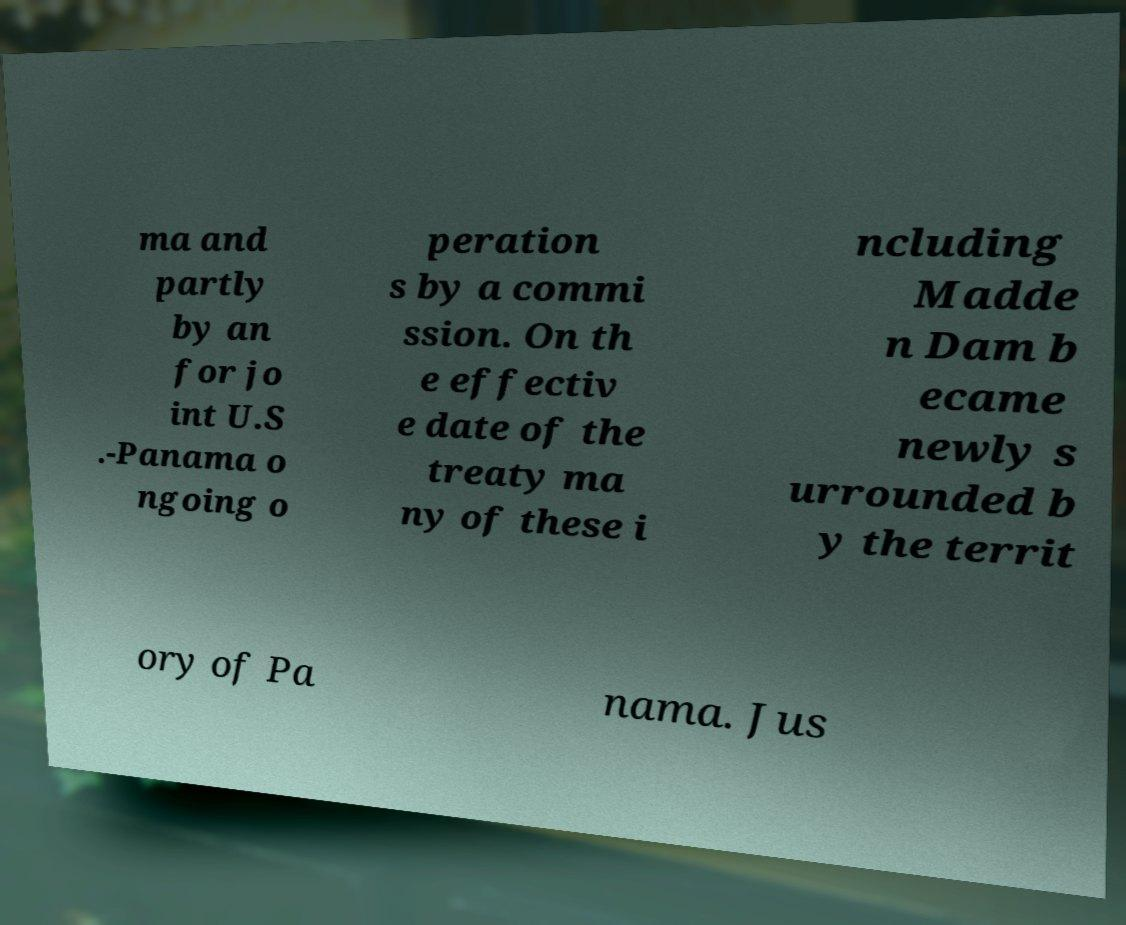Can you read and provide the text displayed in the image?This photo seems to have some interesting text. Can you extract and type it out for me? ma and partly by an for jo int U.S .-Panama o ngoing o peration s by a commi ssion. On th e effectiv e date of the treaty ma ny of these i ncluding Madde n Dam b ecame newly s urrounded b y the territ ory of Pa nama. Jus 